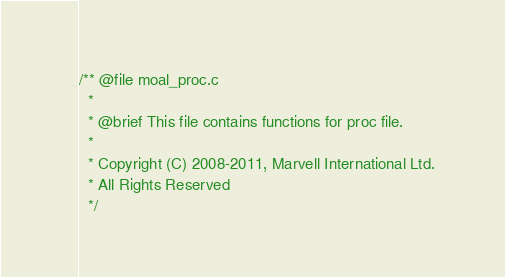Convert code to text. <code><loc_0><loc_0><loc_500><loc_500><_C_>/** @file moal_proc.c
  *
  * @brief This file contains functions for proc file.
  * 
  * Copyright (C) 2008-2011, Marvell International Ltd. 
  * All Rights Reserved
  */
</code> 